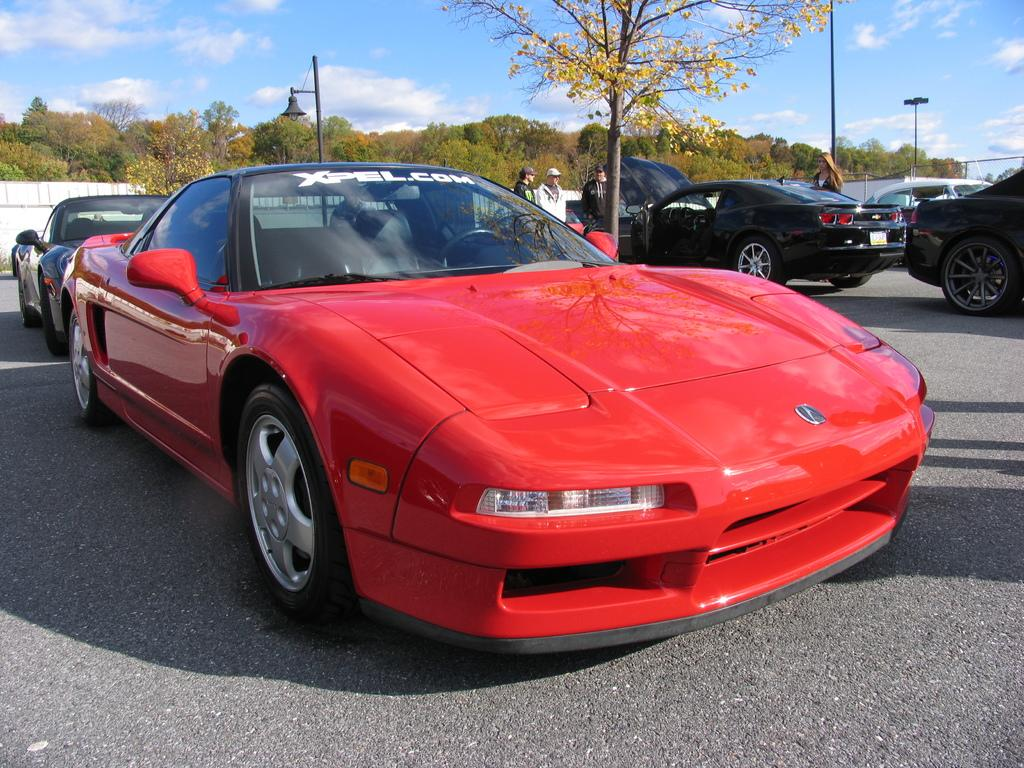What can be seen on the road in the image? There are vehicles and persons on the road in the image. What structures are present in the image? There are poles and a wall in the image. What type of vegetation is visible in the image? There are trees in the image. What is visible in the background of the image? The sky is visible in the background of the image, and there are clouds in the sky. What type of plant is on fire in the image? There is no plant on fire in the image; it only features vehicles, persons, poles, a wall, trees, and a sky with clouds. What type of system is responsible for the organization of the vehicles in the image? There is no specific system mentioned or depicted in the image; it simply shows vehicles and persons on the road. 